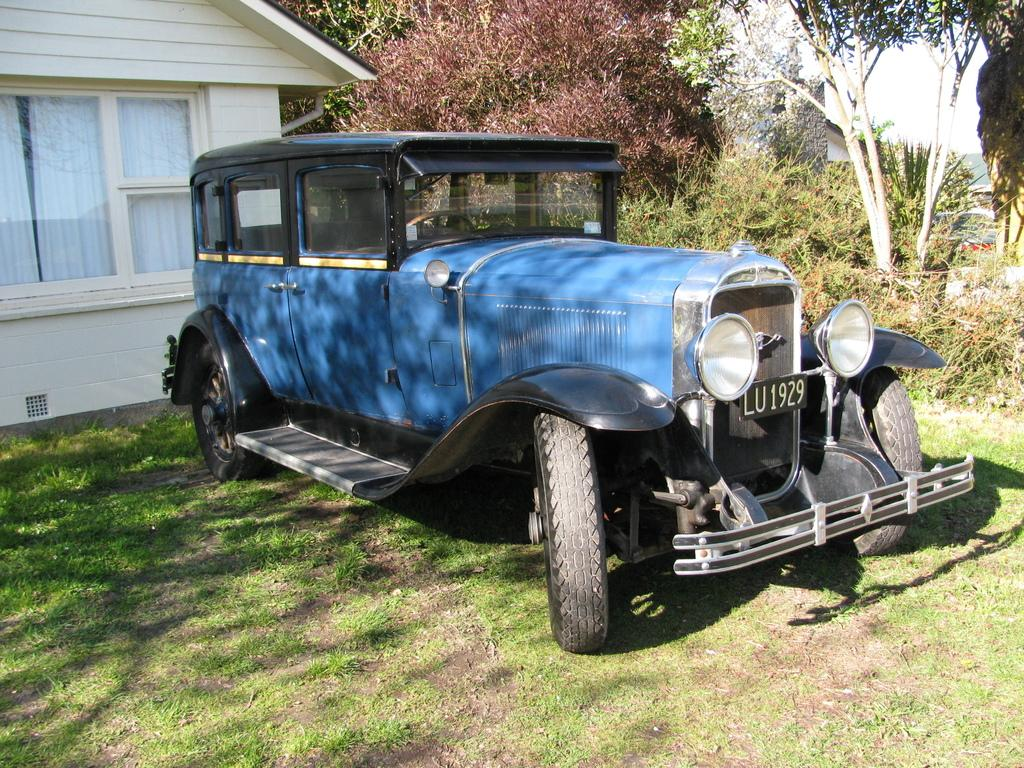What is the main subject in the middle of the image? There is a vehicle on a grassy land in the image, and it is located in the middle. What can be seen on the left side of the image? There is a house on the left side of the image. What type of vegetation is present in the image? The grassy land suggests that there is grass in the image. What is visible in the background of the image? There are trees in the background of the image. How much does the pig weigh on the scale in the image? There is no pig or scale present in the image. 